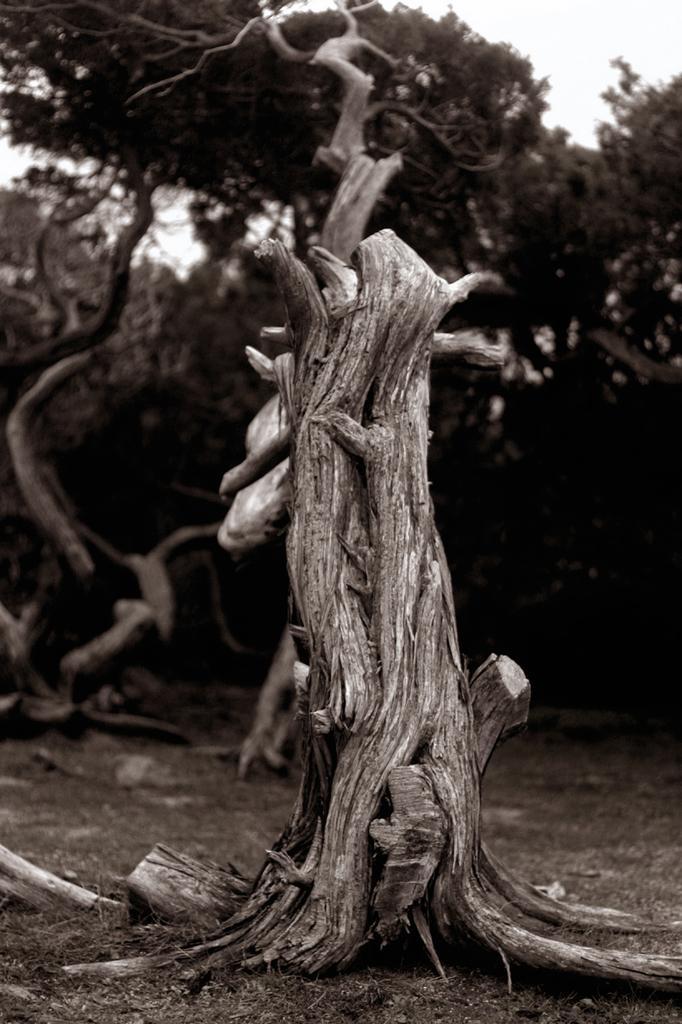Describe this image in one or two sentences. In front of the image there is the trunk of a tree, in the background of the image there are trees. 